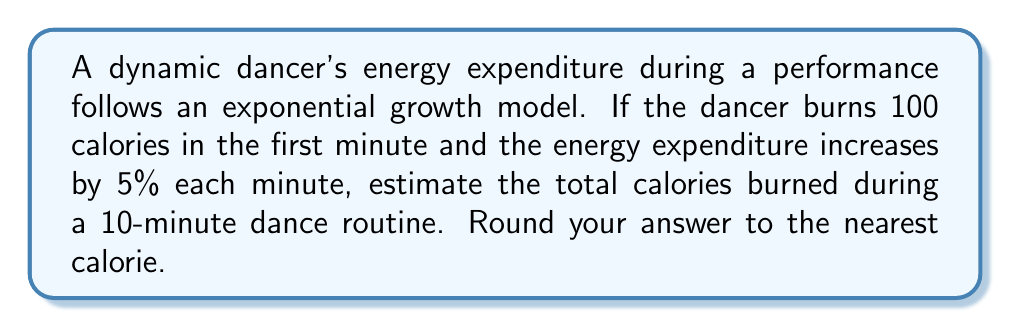Provide a solution to this math problem. Let's approach this step-by-step:

1) The initial energy expenditure is 100 calories per minute.
2) The growth rate is 5% = 0.05 per minute.
3) We need to find the sum of calories burned over 10 minutes.

The exponential growth model for calories burned in minute $t$ is:

$$C(t) = 100 * (1.05)^{t-1}$$

To find the total calories, we need to sum this from $t=1$ to $t=10$:

$$\text{Total Calories} = \sum_{t=1}^{10} 100 * (1.05)^{t-1}$$

This is a geometric series with:
- First term $a = 100$
- Common ratio $r = 1.05$
- Number of terms $n = 10$

We can use the formula for the sum of a geometric series:

$$S_n = a\frac{1-r^n}{1-r}$$

Plugging in our values:

$$\text{Total Calories} = 100 * \frac{1-(1.05)^{10}}{1-1.05}$$

$$= 100 * \frac{1-1.6288946}{-0.05}$$

$$= 100 * \frac{-0.6288946}{-0.05}$$

$$= 100 * 12.577892$$

$$= 1257.7892$$

Rounding to the nearest calorie:

$$\text{Total Calories} \approx 1258 \text{ calories}$$
Answer: 1258 calories 